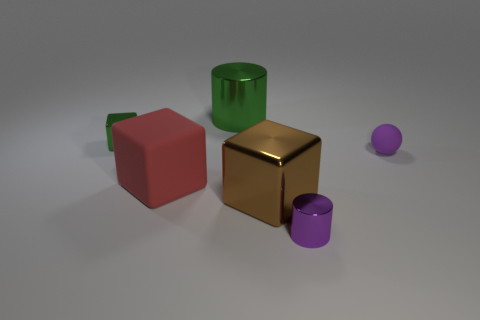Add 4 tiny green things. How many objects exist? 10 Subtract all balls. How many objects are left? 5 Add 6 tiny purple metal things. How many tiny purple metal things exist? 7 Subtract 0 purple blocks. How many objects are left? 6 Subtract all big red metal spheres. Subtract all purple metallic objects. How many objects are left? 5 Add 5 large shiny things. How many large shiny things are left? 7 